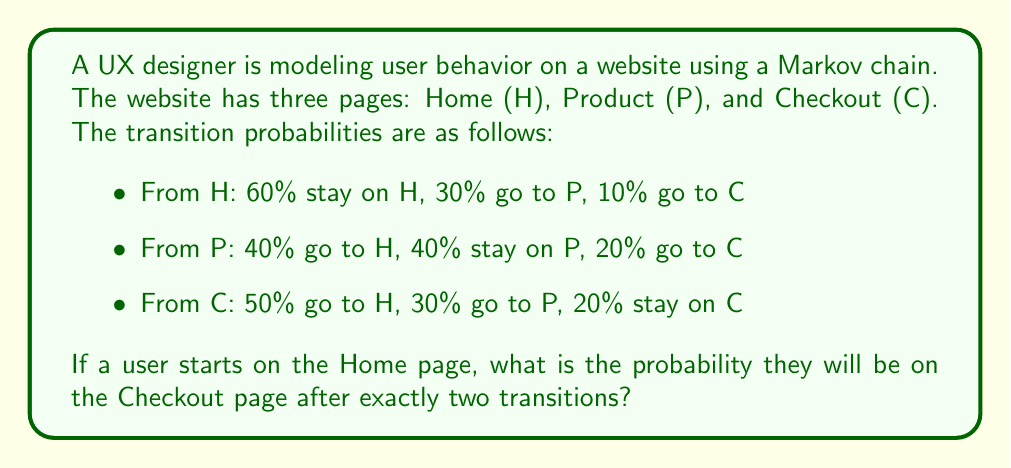Solve this math problem. Let's approach this step-by-step:

1) First, we need to set up the transition matrix $P$ based on the given probabilities:

   $$P = \begin{bmatrix}
   0.6 & 0.3 & 0.1 \\
   0.4 & 0.4 & 0.2 \\
   0.5 & 0.3 & 0.2
   \end{bmatrix}$$

2) The initial state vector, starting from Home, is:

   $$v_0 = \begin{bmatrix} 1 & 0 & 0 \end{bmatrix}$$

3) To find the state after two transitions, we need to multiply the initial state by the transition matrix twice:

   $$v_2 = v_0 \cdot P^2$$

4) Let's calculate $P^2$:

   $$P^2 = \begin{bmatrix}
   0.6 & 0.3 & 0.1 \\
   0.4 & 0.4 & 0.2 \\
   0.5 & 0.3 & 0.2
   \end{bmatrix} \cdot 
   \begin{bmatrix}
   0.6 & 0.3 & 0.1 \\
   0.4 & 0.4 & 0.2 \\
   0.5 & 0.3 & 0.2
   \end{bmatrix}$$

5) Performing the matrix multiplication:

   $$P^2 = \begin{bmatrix}
   0.54 & 0.33 & 0.13 \\
   0.52 & 0.34 & 0.14 \\
   0.53 & 0.33 & 0.14
   \end{bmatrix}$$

6) Now, we can calculate $v_2$:

   $$v_2 = \begin{bmatrix} 1 & 0 & 0 \end{bmatrix} \cdot 
   \begin{bmatrix}
   0.54 & 0.33 & 0.13 \\
   0.52 & 0.34 & 0.14 \\
   0.53 & 0.33 & 0.14
   \end{bmatrix}$$

7) This gives us:

   $$v_2 = \begin{bmatrix} 0.54 & 0.33 & 0.13 \end{bmatrix}$$

8) The probability of being on the Checkout page (C) after two transitions is the third element of this vector: 0.13 or 13%.
Answer: 0.13 